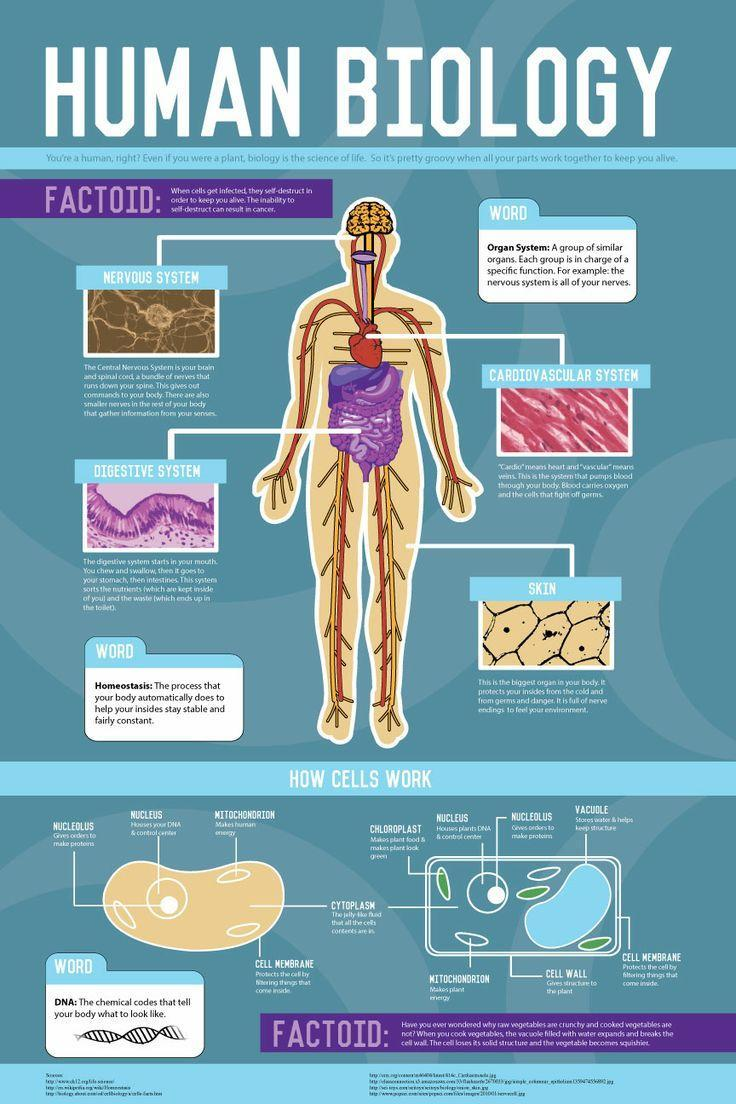How many organ systems are show in the diagram?
Answer the question with a short phrase. 4 